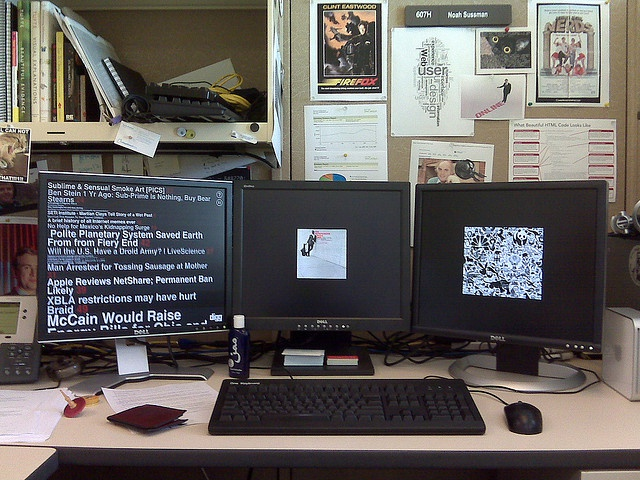Describe the objects in this image and their specific colors. I can see tv in gray, black, and white tones, tv in gray, black, and lightblue tones, tv in gray, black, white, darkgray, and lightblue tones, keyboard in gray, black, and tan tones, and book in gray, darkgray, and black tones in this image. 